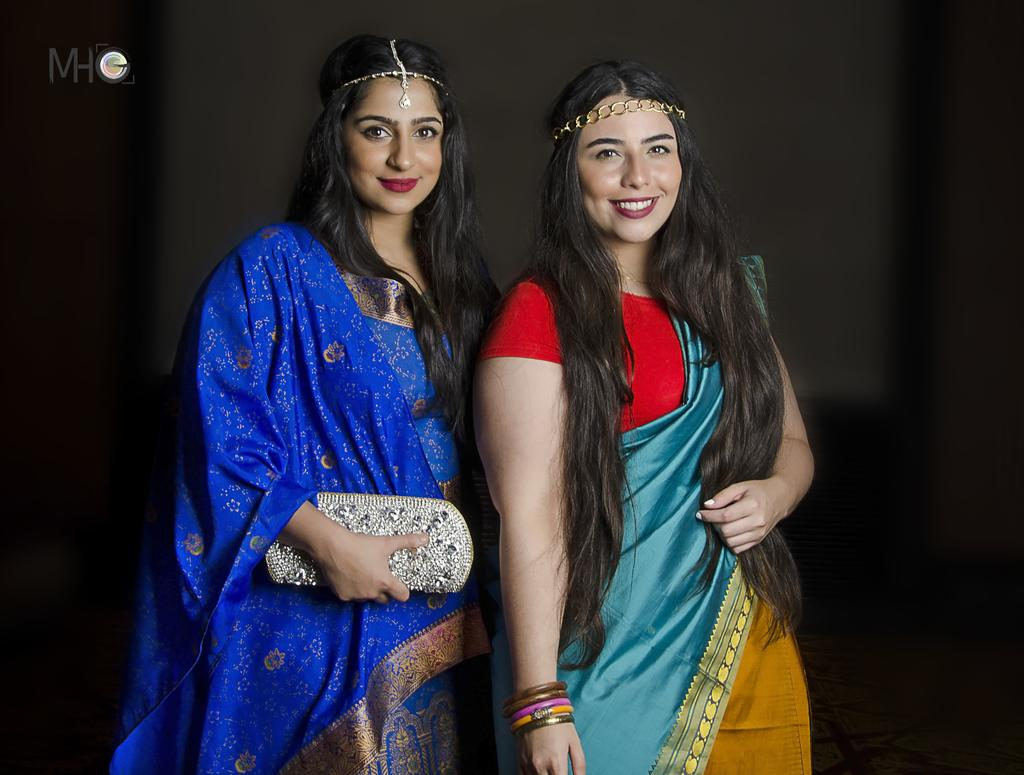How many people are in the image? There are two persons in the image. What is one person holding? One person is holding a purse. What can be seen on the image besides the people? There is text on the image. What is the color of the background in the image? The background of the image is dark. Can you tell me how many horses are visible in the image? There are no horses present in the image. What type of shoes are the people wearing in the image? The provided facts do not mention any shoes, so we cannot determine what type of shoes the people are wearing. 